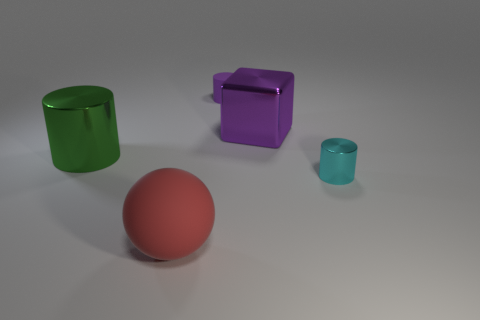Add 2 small green metallic blocks. How many objects exist? 7 Subtract all cylinders. How many objects are left? 2 Add 5 red spheres. How many red spheres are left? 6 Add 5 metallic cubes. How many metallic cubes exist? 6 Subtract 0 brown blocks. How many objects are left? 5 Subtract all large brown rubber cylinders. Subtract all large green metallic objects. How many objects are left? 4 